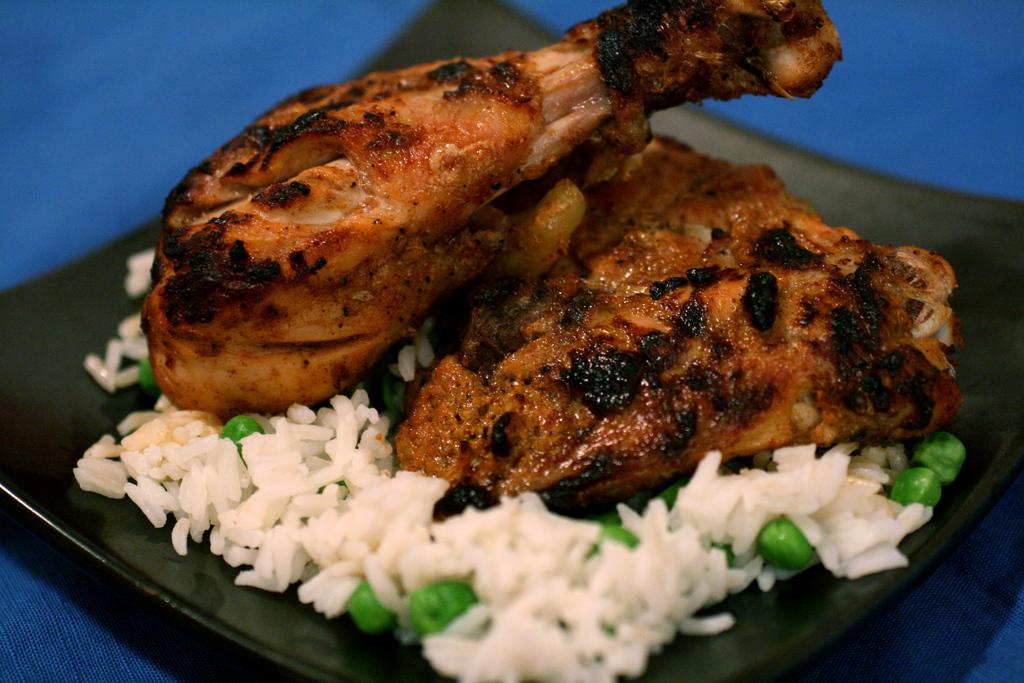What is placed on a plate in the image? There is food placed on a plate in the image. What type of car is parked next to the plate in the image? There is no car present in the image; it only shows food placed on a plate. 